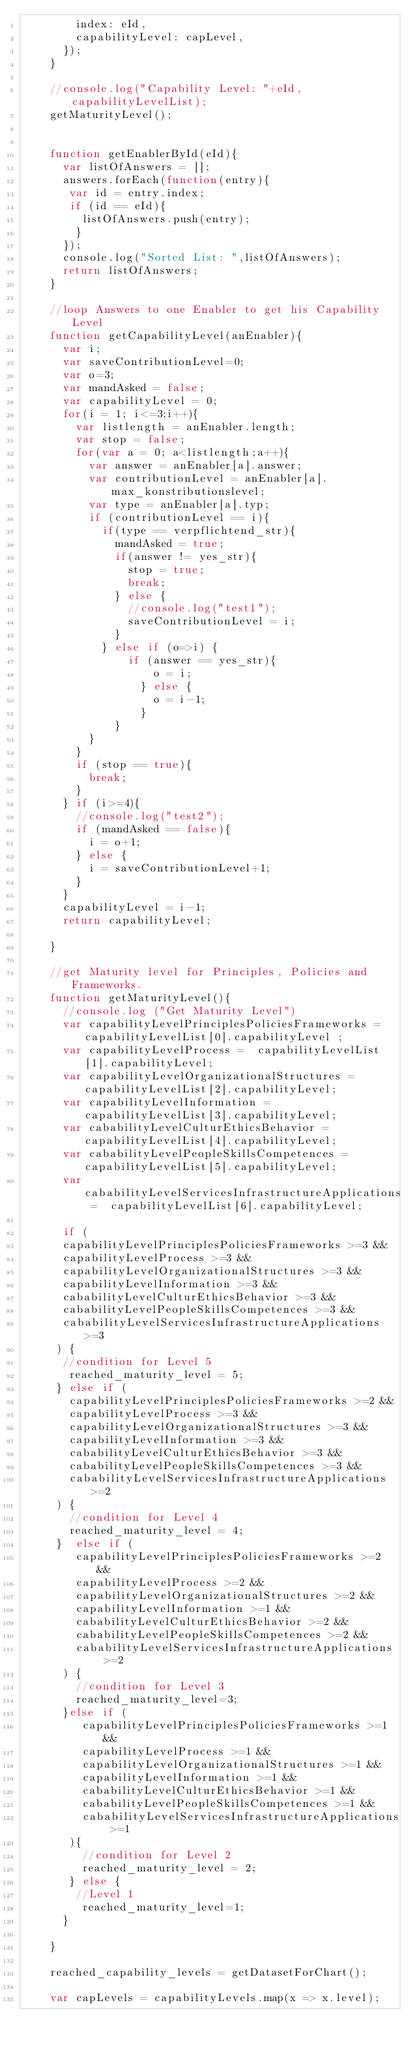<code> <loc_0><loc_0><loc_500><loc_500><_JavaScript_>				index: eId,
				capabilityLevel: capLevel,
			});
		}

		//console.log("Capability Level: "+eId,capabilityLevelList);
		getMaturityLevel();


		function getEnablerById(eId){
			var listOfAnswers = [];
			answers.forEach(function(entry){
			 var id = entry.index;
			 if (id == eId){
				 listOfAnswers.push(entry);
				}
			});
			console.log("Sorted List: ",listOfAnswers);
			return listOfAnswers;
		}

		//loop Answers to one Enabler to get his Capability Level
		function getCapabilityLevel(anEnabler){
			var i;
			var saveContributionLevel=0;
			var o=3;
			var mandAsked = false;
			var capabilityLevel = 0;
			for(i = 1; i<=3;i++){
				var listlength = anEnabler.length;
				var stop = false;
				for(var a = 0; a<listlength;a++){
					var answer = anEnabler[a].answer;
					var contributionLevel = anEnabler[a].max_konstributionslevel;
	 			  var type = anEnabler[a].typ;
					if (contributionLevel == i){
						if(type == verpflichtend_str){
							mandAsked = true;
							if(answer != yes_str){
								stop = true;
								break;
							} else {
								//console.log("test1");
								saveContributionLevel = i;
							}
						} else if (o=>i) {
							 	if (answer == yes_str){
										o = i;
									} else {
										o = i-1;
									}
						  }
					}
				}
				if (stop == true){
					break;
				}
			} if (i>=4){
				//console.log("test2");
				if (mandAsked == false){
					i = o+1;
				} else {
					i = saveContributionLevel+1;
				}
			}
			capabilityLevel = i-1;
			return capabilityLevel;

		}

		//get Maturity level for Principles, Policies and Frameworks.
		function getMaturityLevel(){
			//console.log ("Get Maturity Level")
			var capabilityLevelPrinciplesPoliciesFrameworks = capabilityLevelList[0].capabilityLevel ;
			var capabilityLevelProcess =  capabilityLevelList[1].capabilityLevel;
			var capabilityLevelOrganizationalStructures =  capabilityLevelList[2].capabilityLevel;
			var capabilityLevelInformation =  capabilityLevelList[3].capabilityLevel;
			var cababilityLevelCulturEthicsBehavior =  capabilityLevelList[4].capabilityLevel;
			var cababilityLevelPeopleSkillsCompetences =  capabilityLevelList[5].capabilityLevel;
			var cababilityLevelServicesInfrastructureApplications =  capabilityLevelList[6].capabilityLevel;

		  if (
		 	capabilityLevelPrinciplesPoliciesFrameworks >=3 &&
		 	capabilityLevelProcess >=3 &&
		 	capabilityLevelOrganizationalStructures >=3 &&
		 	capabilityLevelInformation >=3 &&
		 	cababilityLevelCulturEthicsBehavior >=3 &&
		 	cababilityLevelPeopleSkillsCompetences >=3 &&
		 	cababilityLevelServicesInfrastructureApplications >=3
		 ) {
		 	//condition for Level 5
		 	 reached_maturity_level = 5;
		 } else if (
			 capabilityLevelPrinciplesPoliciesFrameworks >=2 &&
			 capabilityLevelProcess >=3 &&
			 capabilityLevelOrganizationalStructures >=3 &&
			 capabilityLevelInformation >=3 &&
			 cababilityLevelCulturEthicsBehavior >=3 &&
			 cababilityLevelPeopleSkillsCompetences >=3 &&
			 cababilityLevelServicesInfrastructureApplications >=2
		 ) {
			 //condition for Level 4
			 reached_maturity_level = 4;
		 }  else if (
				capabilityLevelPrinciplesPoliciesFrameworks >=2 &&
				capabilityLevelProcess >=2 &&
				capabilityLevelOrganizationalStructures >=2 &&
				capabilityLevelInformation >=1 &&
				cababilityLevelCulturEthicsBehavior >=2 &&
				cababilityLevelPeopleSkillsCompetences >=2 &&
				cababilityLevelServicesInfrastructureApplications >=2
			) {
				//condition for Level 3
				reached_maturity_level=3;
			}else if (
				 capabilityLevelPrinciplesPoliciesFrameworks >=1 &&
				 capabilityLevelProcess >=1 &&
				 capabilityLevelOrganizationalStructures >=1 &&
				 capabilityLevelInformation >=1 &&
				 cababilityLevelCulturEthicsBehavior >=1 &&
				 cababilityLevelPeopleSkillsCompetences >=1 &&
				 cababilityLevelServicesInfrastructureApplications >=1
			 ){
				 //condition for Level 2
				 reached_maturity_level = 2;
			 } else {
				//Level 1
				 reached_maturity_level=1;
			}

		}

		reached_capability_levels = getDatasetForChart();

		var capLevels = capabilityLevels.map(x => x.level);</code> 